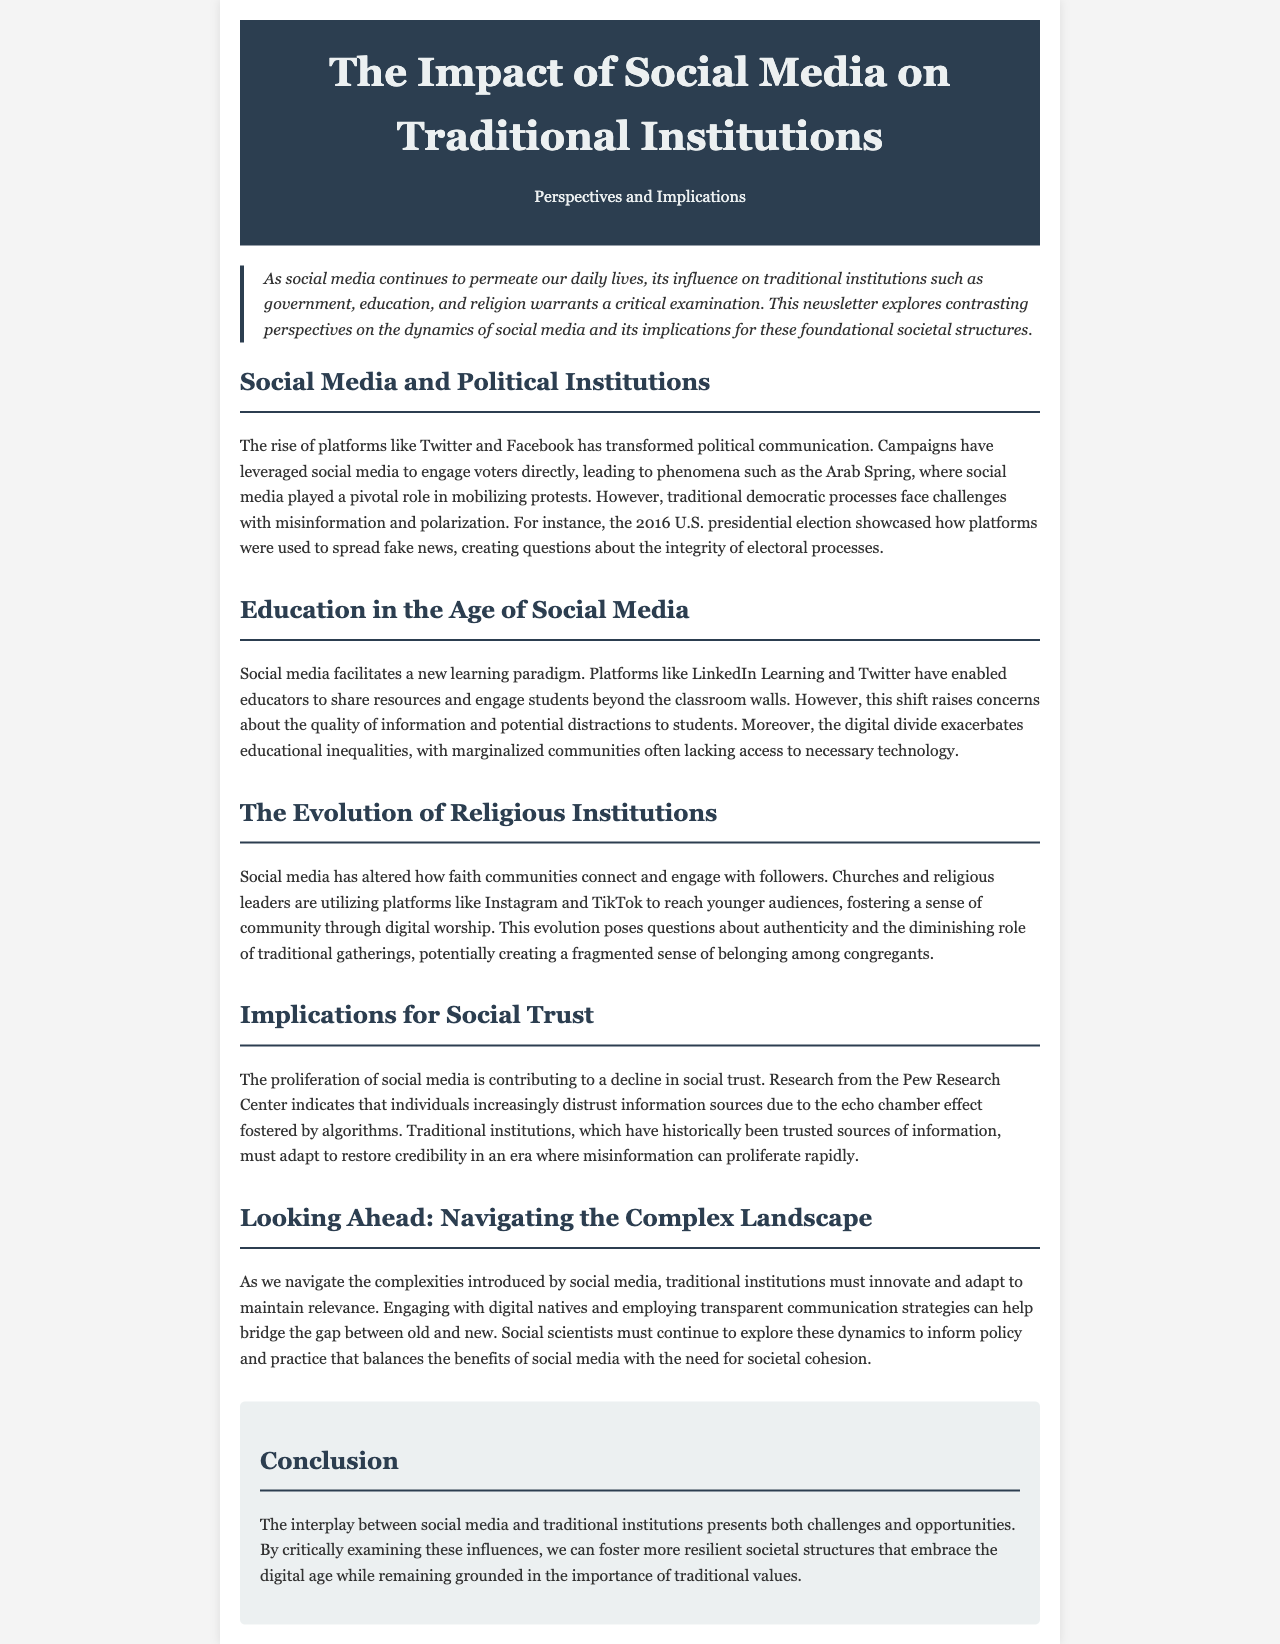what role did social media play in the Arab Spring? The document states that social media played a pivotal role in mobilizing protests during the Arab Spring.
Answer: mobilizing protests what are the two platforms mentioned that have transformed political communication? The document mentions Twitter and Facebook as key platforms transforming political communication.
Answer: Twitter and Facebook which community is mentioned as facing educational inequalities due to the digital divide? The document indicates that marginalized communities often lack access to necessary technology, leading to educational inequalities.
Answer: marginalized communities what is the primary concern regarding the shift in education due to social media? The document raises concerns about the quality of information and potential distractions to students as primary concerns regarding the shift in education due to social media.
Answer: quality of information and distractions how are religious institutions engaging with younger audiences according to the document? The document mentions that churches and religious leaders are utilizing platforms like Instagram and TikTok to reach younger audiences.
Answer: Instagram and TikTok what effect is social media having on social trust? The document discusses a decline in social trust as a significant effect of the proliferation of social media.
Answer: decline in social trust what must traditional institutions do to maintain relevance? The document suggests that traditional institutions must innovate and adapt to maintain relevance in the digital age.
Answer: innovate and adapt what type of strategies should traditional institutions employ? The document advises that employing transparent communication strategies can help traditional institutions bridge the gap between old and new.
Answer: transparent communication strategies what is the document type of this content? The content is presented in the format of a newsletter exploring social media's impact on traditional institutions.
Answer: newsletter 